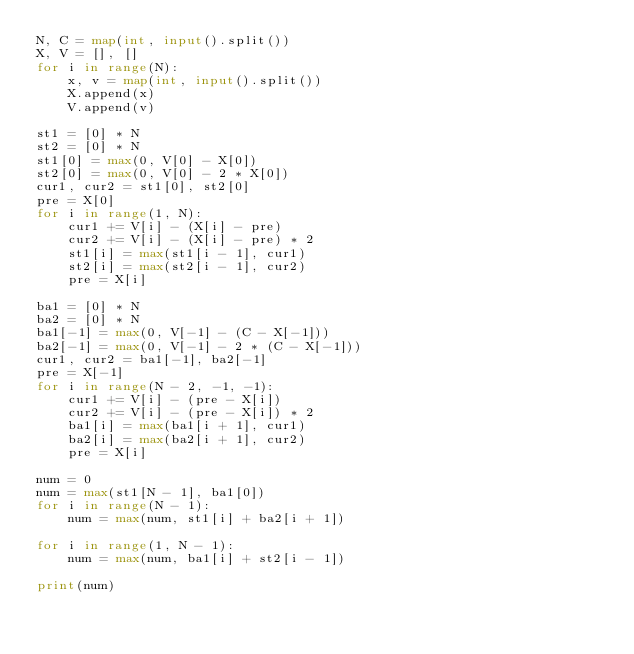<code> <loc_0><loc_0><loc_500><loc_500><_Python_>N, C = map(int, input().split())
X, V = [], []
for i in range(N):
    x, v = map(int, input().split())
    X.append(x)
    V.append(v)

st1 = [0] * N
st2 = [0] * N
st1[0] = max(0, V[0] - X[0])
st2[0] = max(0, V[0] - 2 * X[0])
cur1, cur2 = st1[0], st2[0]
pre = X[0]
for i in range(1, N):
    cur1 += V[i] - (X[i] - pre)
    cur2 += V[i] - (X[i] - pre) * 2
    st1[i] = max(st1[i - 1], cur1)
    st2[i] = max(st2[i - 1], cur2)
    pre = X[i]

ba1 = [0] * N
ba2 = [0] * N
ba1[-1] = max(0, V[-1] - (C - X[-1]))
ba2[-1] = max(0, V[-1] - 2 * (C - X[-1]))
cur1, cur2 = ba1[-1], ba2[-1]
pre = X[-1]
for i in range(N - 2, -1, -1):
    cur1 += V[i] - (pre - X[i])
    cur2 += V[i] - (pre - X[i]) * 2
    ba1[i] = max(ba1[i + 1], cur1)
    ba2[i] = max(ba2[i + 1], cur2)
    pre = X[i]

num = 0
num = max(st1[N - 1], ba1[0])
for i in range(N - 1):
    num = max(num, st1[i] + ba2[i + 1])

for i in range(1, N - 1):
    num = max(num, ba1[i] + st2[i - 1])

print(num)
</code> 